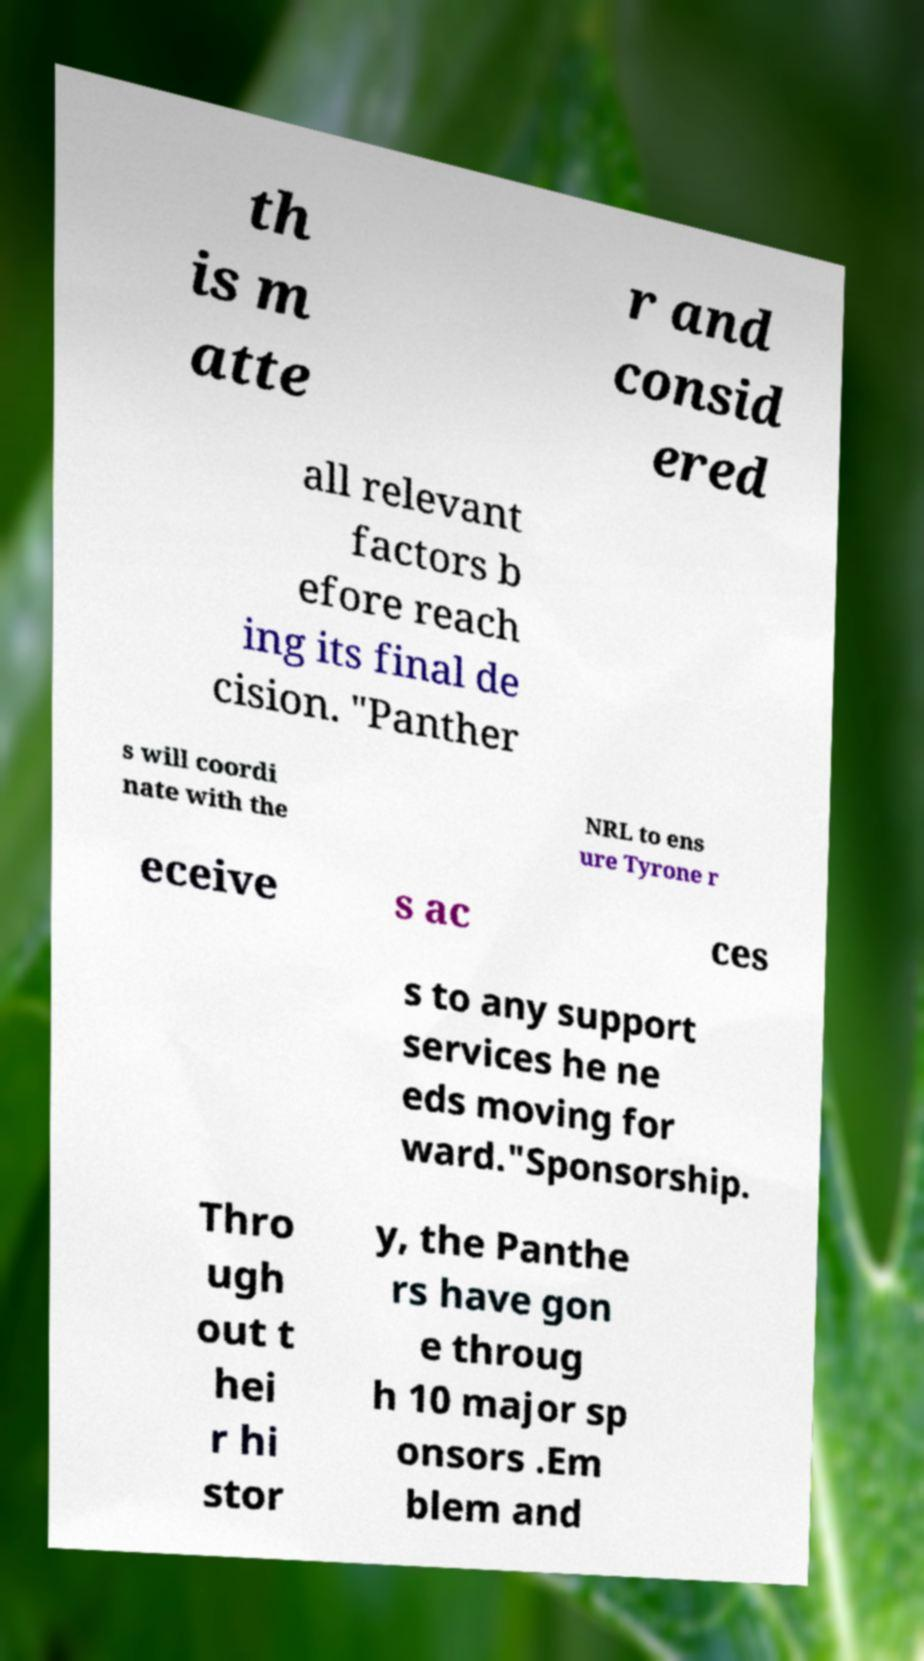What messages or text are displayed in this image? I need them in a readable, typed format. th is m atte r and consid ered all relevant factors b efore reach ing its final de cision. "Panther s will coordi nate with the NRL to ens ure Tyrone r eceive s ac ces s to any support services he ne eds moving for ward."Sponsorship. Thro ugh out t hei r hi stor y, the Panthe rs have gon e throug h 10 major sp onsors .Em blem and 